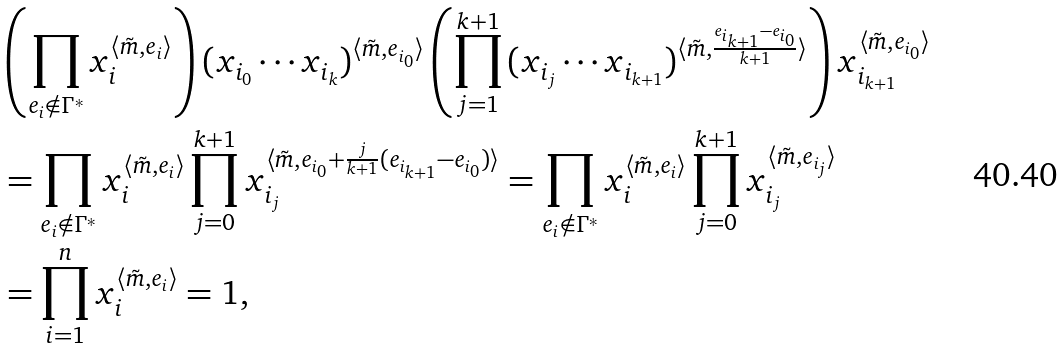Convert formula to latex. <formula><loc_0><loc_0><loc_500><loc_500>& \left ( \prod _ { e _ { i } \notin \Gamma ^ { * } } x _ { i } ^ { \langle \tilde { m } , e _ { i } \rangle } \right ) { ( x _ { i _ { 0 } } \cdots x _ { i _ { k } } ) } ^ { \langle \tilde { m } , e _ { i _ { 0 } } \rangle } \left ( \prod _ { j = 1 } ^ { k + 1 } { ( x _ { i _ { j } } \cdots x _ { i _ { k + 1 } } ) } ^ { \langle \tilde { m } , \frac { e _ { i _ { k + 1 } } - e _ { i _ { 0 } } } { k + 1 } \rangle } \right ) x _ { i _ { k + 1 } } ^ { \langle \tilde { m } , e _ { i _ { 0 } } \rangle } \\ & = \prod _ { e _ { i } \notin \Gamma ^ { * } } x _ { i } ^ { \langle \tilde { m } , e _ { i } \rangle } \prod _ { j = 0 } ^ { k + 1 } x _ { i _ { j } } ^ { \langle \tilde { m } , e _ { i _ { 0 } } + \frac { j } { k + 1 } ( e _ { i _ { k + 1 } } - e _ { i _ { 0 } } ) \rangle } = \prod _ { e _ { i } \notin \Gamma ^ { * } } x _ { i } ^ { \langle \tilde { m } , e _ { i } \rangle } \prod _ { j = 0 } ^ { k + 1 } x _ { i _ { j } } ^ { \langle \tilde { m } , e _ { i _ { j } } \rangle } \\ & = \prod _ { i = 1 } ^ { n } x _ { i } ^ { \langle \tilde { m } , e _ { i } \rangle } = 1 ,</formula> 